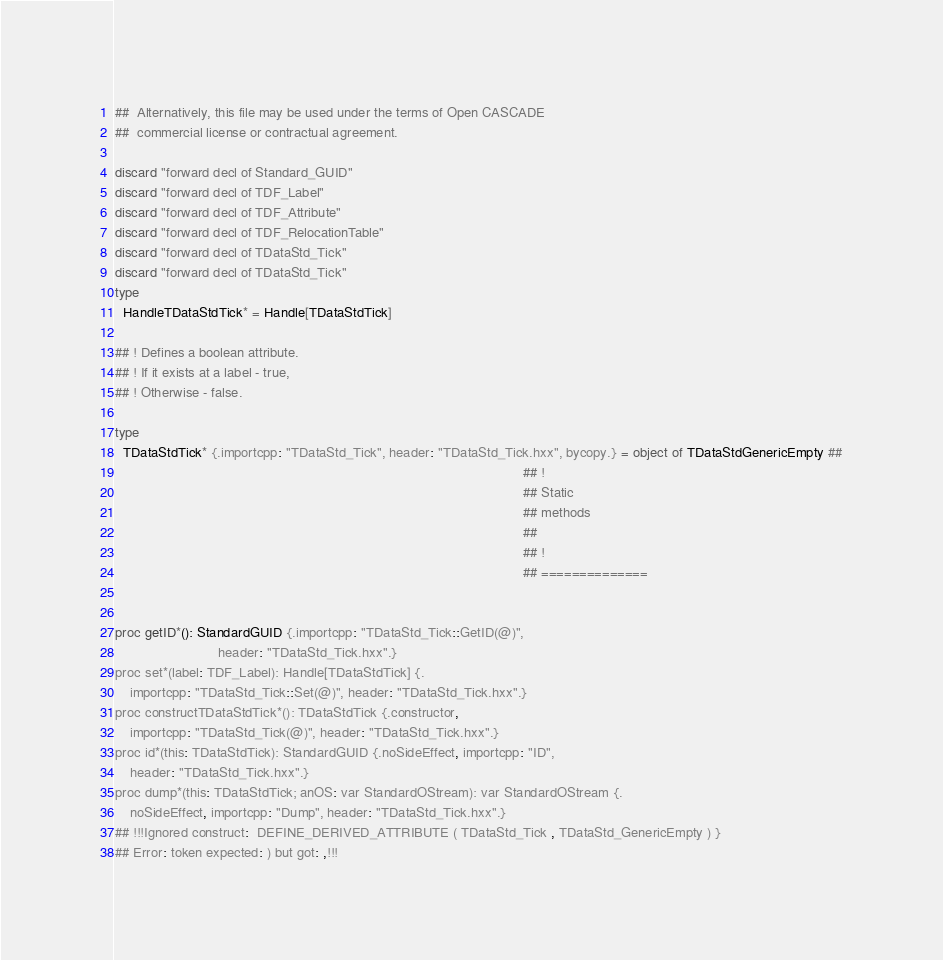<code> <loc_0><loc_0><loc_500><loc_500><_Nim_>##  Alternatively, this file may be used under the terms of Open CASCADE
##  commercial license or contractual agreement.

discard "forward decl of Standard_GUID"
discard "forward decl of TDF_Label"
discard "forward decl of TDF_Attribute"
discard "forward decl of TDF_RelocationTable"
discard "forward decl of TDataStd_Tick"
discard "forward decl of TDataStd_Tick"
type
  HandleTDataStdTick* = Handle[TDataStdTick]

## ! Defines a boolean attribute.
## ! If it exists at a label - true,
## ! Otherwise - false.

type
  TDataStdTick* {.importcpp: "TDataStd_Tick", header: "TDataStd_Tick.hxx", bycopy.} = object of TDataStdGenericEmpty ##
                                                                                                           ## !
                                                                                                           ## Static
                                                                                                           ## methods
                                                                                                           ##
                                                                                                           ## !
                                                                                                           ## ==============


proc getID*(): StandardGUID {.importcpp: "TDataStd_Tick::GetID(@)",
                           header: "TDataStd_Tick.hxx".}
proc set*(label: TDF_Label): Handle[TDataStdTick] {.
    importcpp: "TDataStd_Tick::Set(@)", header: "TDataStd_Tick.hxx".}
proc constructTDataStdTick*(): TDataStdTick {.constructor,
    importcpp: "TDataStd_Tick(@)", header: "TDataStd_Tick.hxx".}
proc id*(this: TDataStdTick): StandardGUID {.noSideEffect, importcpp: "ID",
    header: "TDataStd_Tick.hxx".}
proc dump*(this: TDataStdTick; anOS: var StandardOStream): var StandardOStream {.
    noSideEffect, importcpp: "Dump", header: "TDataStd_Tick.hxx".}
## !!!Ignored construct:  DEFINE_DERIVED_ATTRIBUTE ( TDataStd_Tick , TDataStd_GenericEmpty ) }
## Error: token expected: ) but got: ,!!!















































</code> 